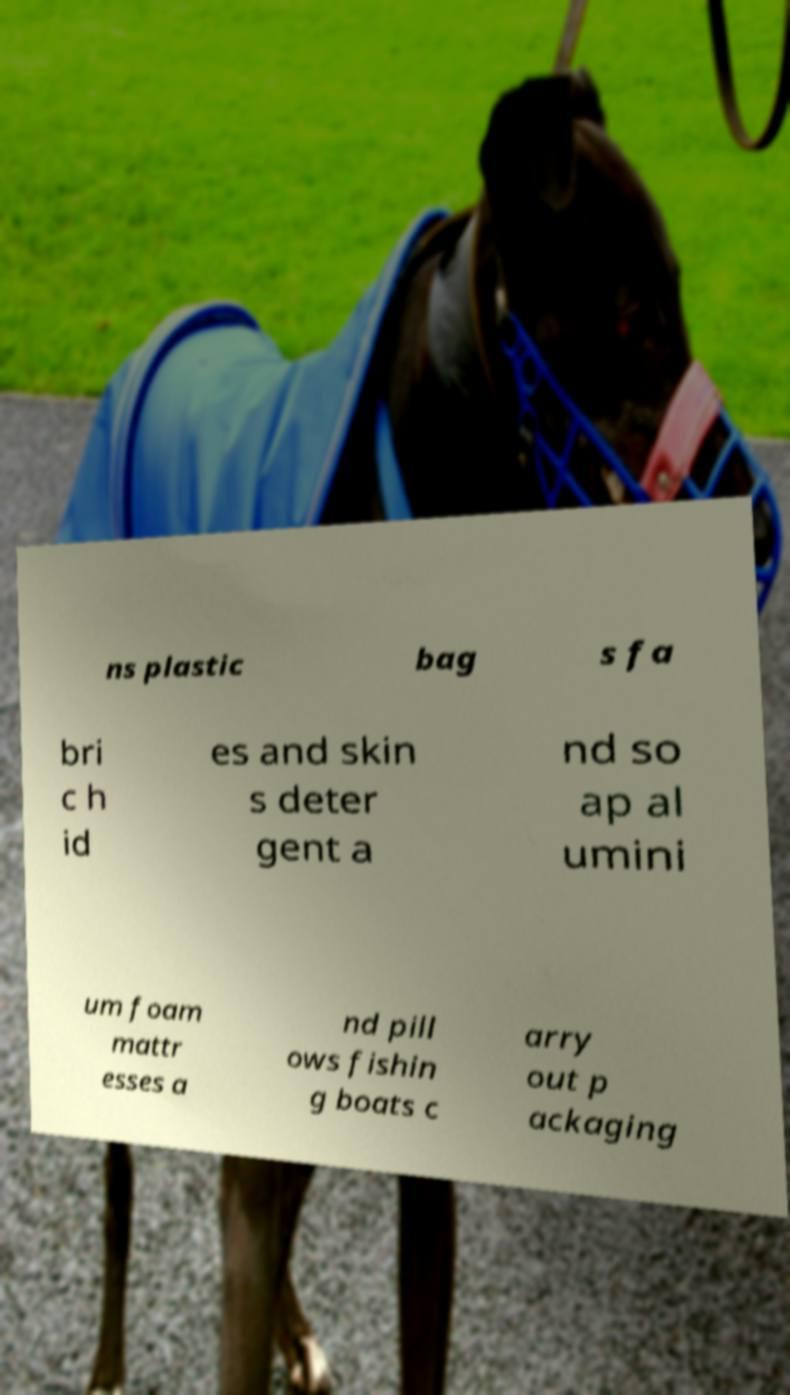Please identify and transcribe the text found in this image. ns plastic bag s fa bri c h id es and skin s deter gent a nd so ap al umini um foam mattr esses a nd pill ows fishin g boats c arry out p ackaging 